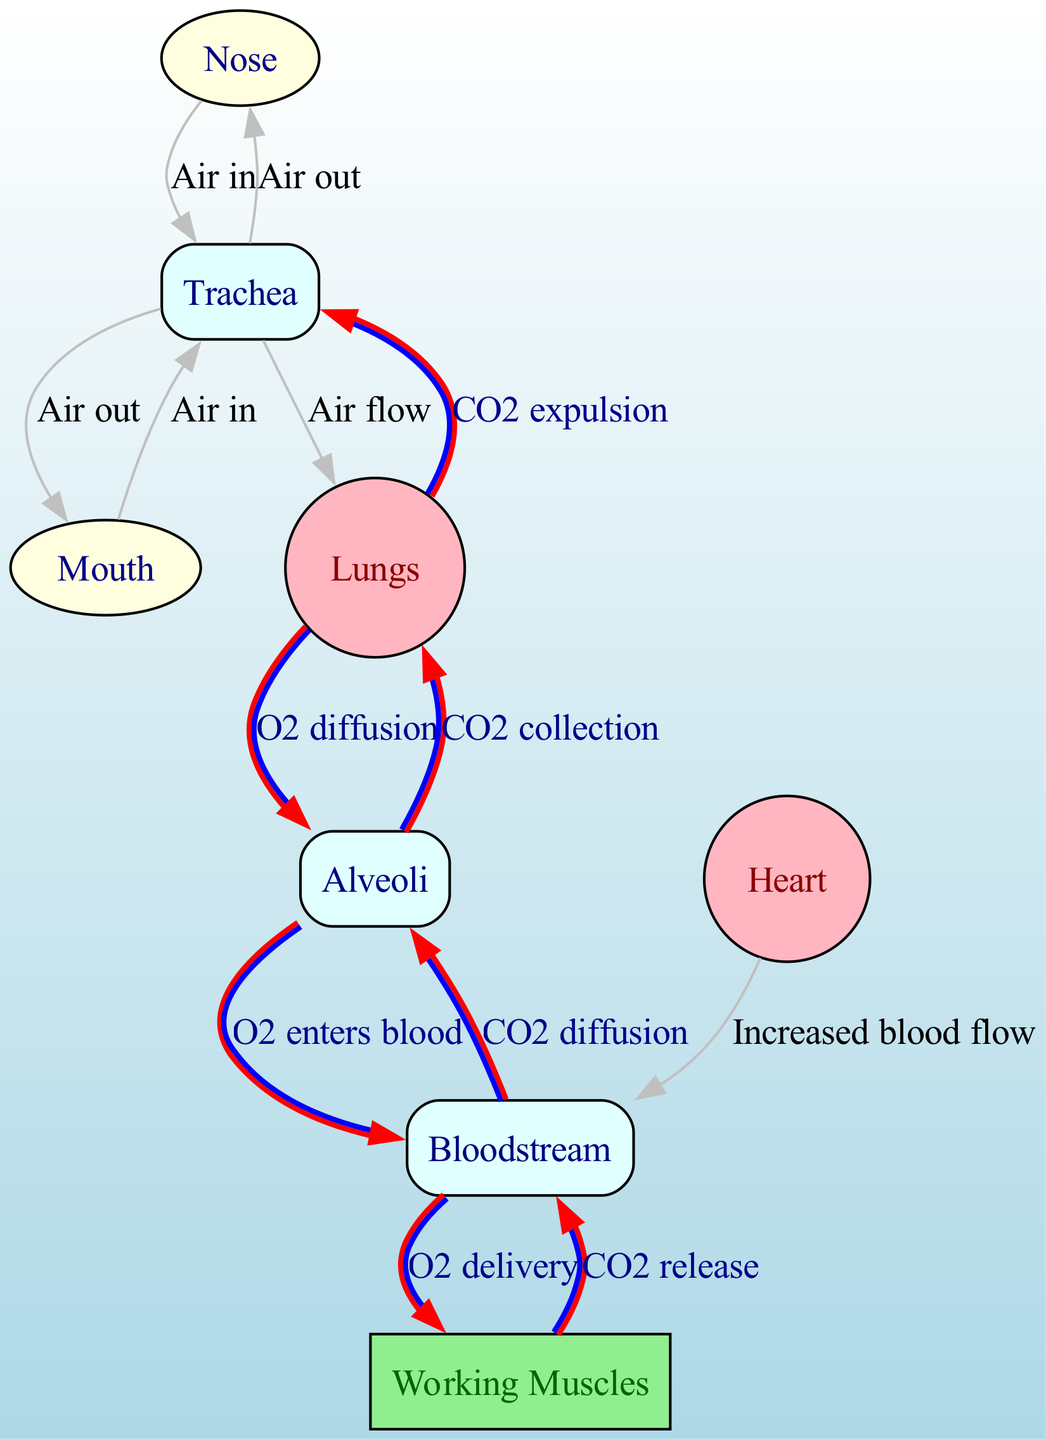What is the first node that air enters into during inhalation? According to the diagram, the first nodes are the nose and mouth, where air enters either through breathing or speaking. Since both nodes are part of the initial entry, the answer would be either of them, but the question specifies "the first," where the nose is typically considered the primary route for air entry.
Answer: Nose How many edges are there in total in the diagram? The diagram shows relationships between various nodes through edges. By counting all the connections depicted, we find there are 11 edges connecting the nodes in the respiratory system.
Answer: 11 What is the function of the alveoli in this diagram? The alveoli serve two significant functions: diffusion of oxygen into blood and diffusion of carbon dioxide back to the lungs for expulsion. The arrows indicating these functions show that oxygen enters the bloodstream from alveoli and carbon dioxide diffuses from the bloodstream to alveoli.
Answer: O2 diffusion and CO2 diffusion Which node receives increased blood flow as indicated in the diagram? The diagram shows a direct edge from the heart to bloodstream labeled "Increased blood flow." Therefore, it's evident that the heart is responsible for delivering this increased flow to the bloodstream.
Answer: Heart What is the label on the edge connecting the bloodstream to the muscles? The edge connecting the bloodstream to the muscles is labeled "O2 delivery," indicating the transfer of oxygen from the blood to the working muscles during aerobic exercise.
Answer: O2 delivery How does carbon dioxide enter the alveoli from the bloodstream? The diagram indicates that carbon dioxide enters the alveoli from the bloodstream through the labeled edge "CO2 diffusion." This signifies the process whereby CO2 moves from blood to alveoli for collection and subsequent expulsion.
Answer: CO2 diffusion Which structure is responsible for the collection of carbon dioxide before expiration? In the diagram, the alveoli are where carbon dioxide is collected before being expelled from the body. The relationship indicated directly connects the arteries to the alveoli, highlighting their role in this process.
Answer: Alveoli What is the relationship between the lungs and trachea during exhalation? During exhalation, the relationship shown in the diagram between the lungs and trachea is specified by the edge labeled "CO2 expulsion," indicating the process of moving carbon dioxide from the lungs to the trachea for leaving the body.
Answer: CO2 expulsion 